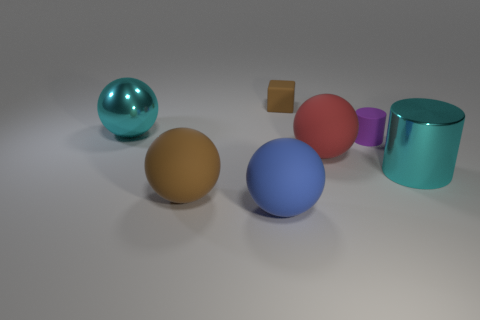Add 2 small blue cylinders. How many objects exist? 9 Subtract all large blue matte balls. How many balls are left? 3 Subtract all cyan cylinders. How many cylinders are left? 1 Subtract all cylinders. How many objects are left? 5 Subtract 1 cylinders. How many cylinders are left? 1 Subtract 1 red balls. How many objects are left? 6 Subtract all blue spheres. Subtract all gray cylinders. How many spheres are left? 3 Subtract all large metal spheres. Subtract all big matte things. How many objects are left? 3 Add 2 red matte spheres. How many red matte spheres are left? 3 Add 6 metal cylinders. How many metal cylinders exist? 7 